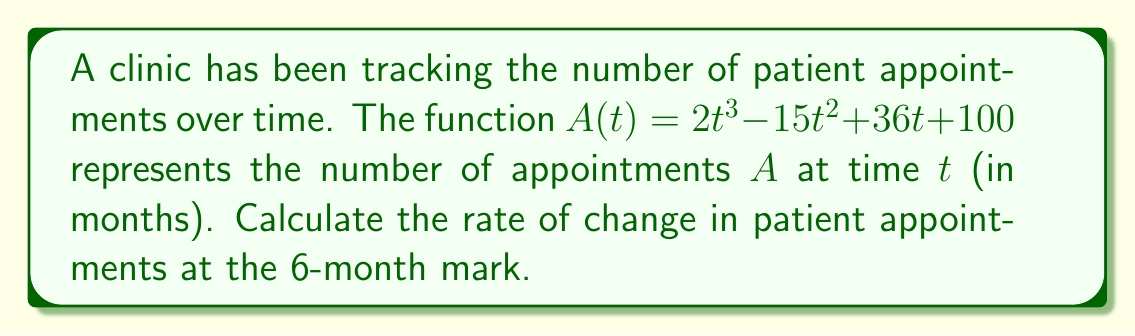Teach me how to tackle this problem. To find the rate of change in patient appointments at a specific time, we need to calculate the derivative of the function $A(t)$ and evaluate it at $t=6$.

Step 1: Find the derivative of $A(t)$.
$$\frac{d}{dt}A(t) = \frac{d}{dt}(2t^3 - 15t^2 + 36t + 100)$$
$$A'(t) = 6t^2 - 30t + 36$$

Step 2: Evaluate $A'(t)$ at $t=6$.
$$A'(6) = 6(6)^2 - 30(6) + 36$$
$$A'(6) = 6(36) - 180 + 36$$
$$A'(6) = 216 - 180 + 36$$
$$A'(6) = 72$$

The rate of change at $t=6$ months is 72 appointments per month.
Answer: 72 appointments/month 